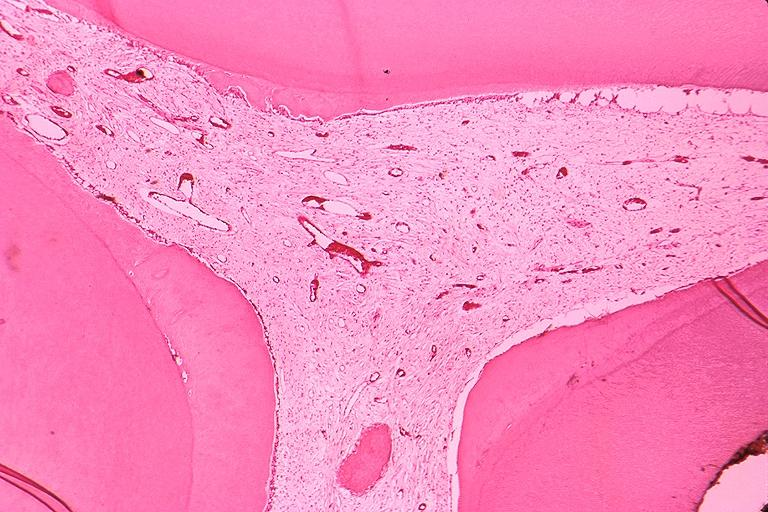what does this image show?
Answer the question using a single word or phrase. Secondary dentin and pulp calcification 